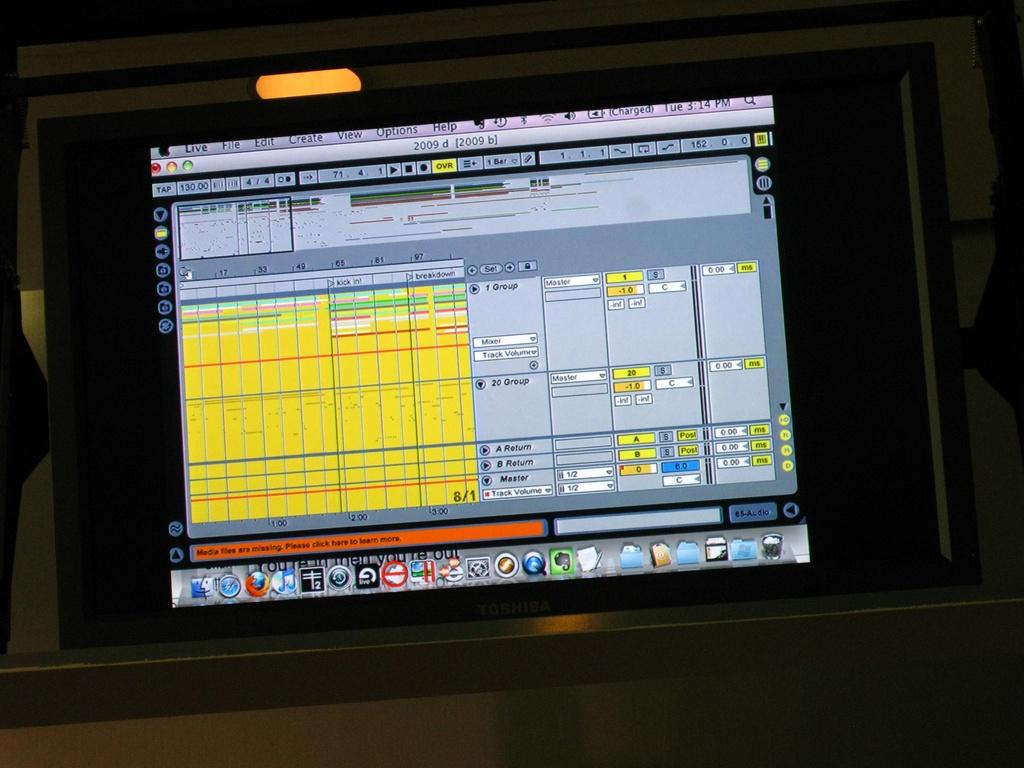<image>
Offer a succinct explanation of the picture presented. A computer screen, that says media files are missing 